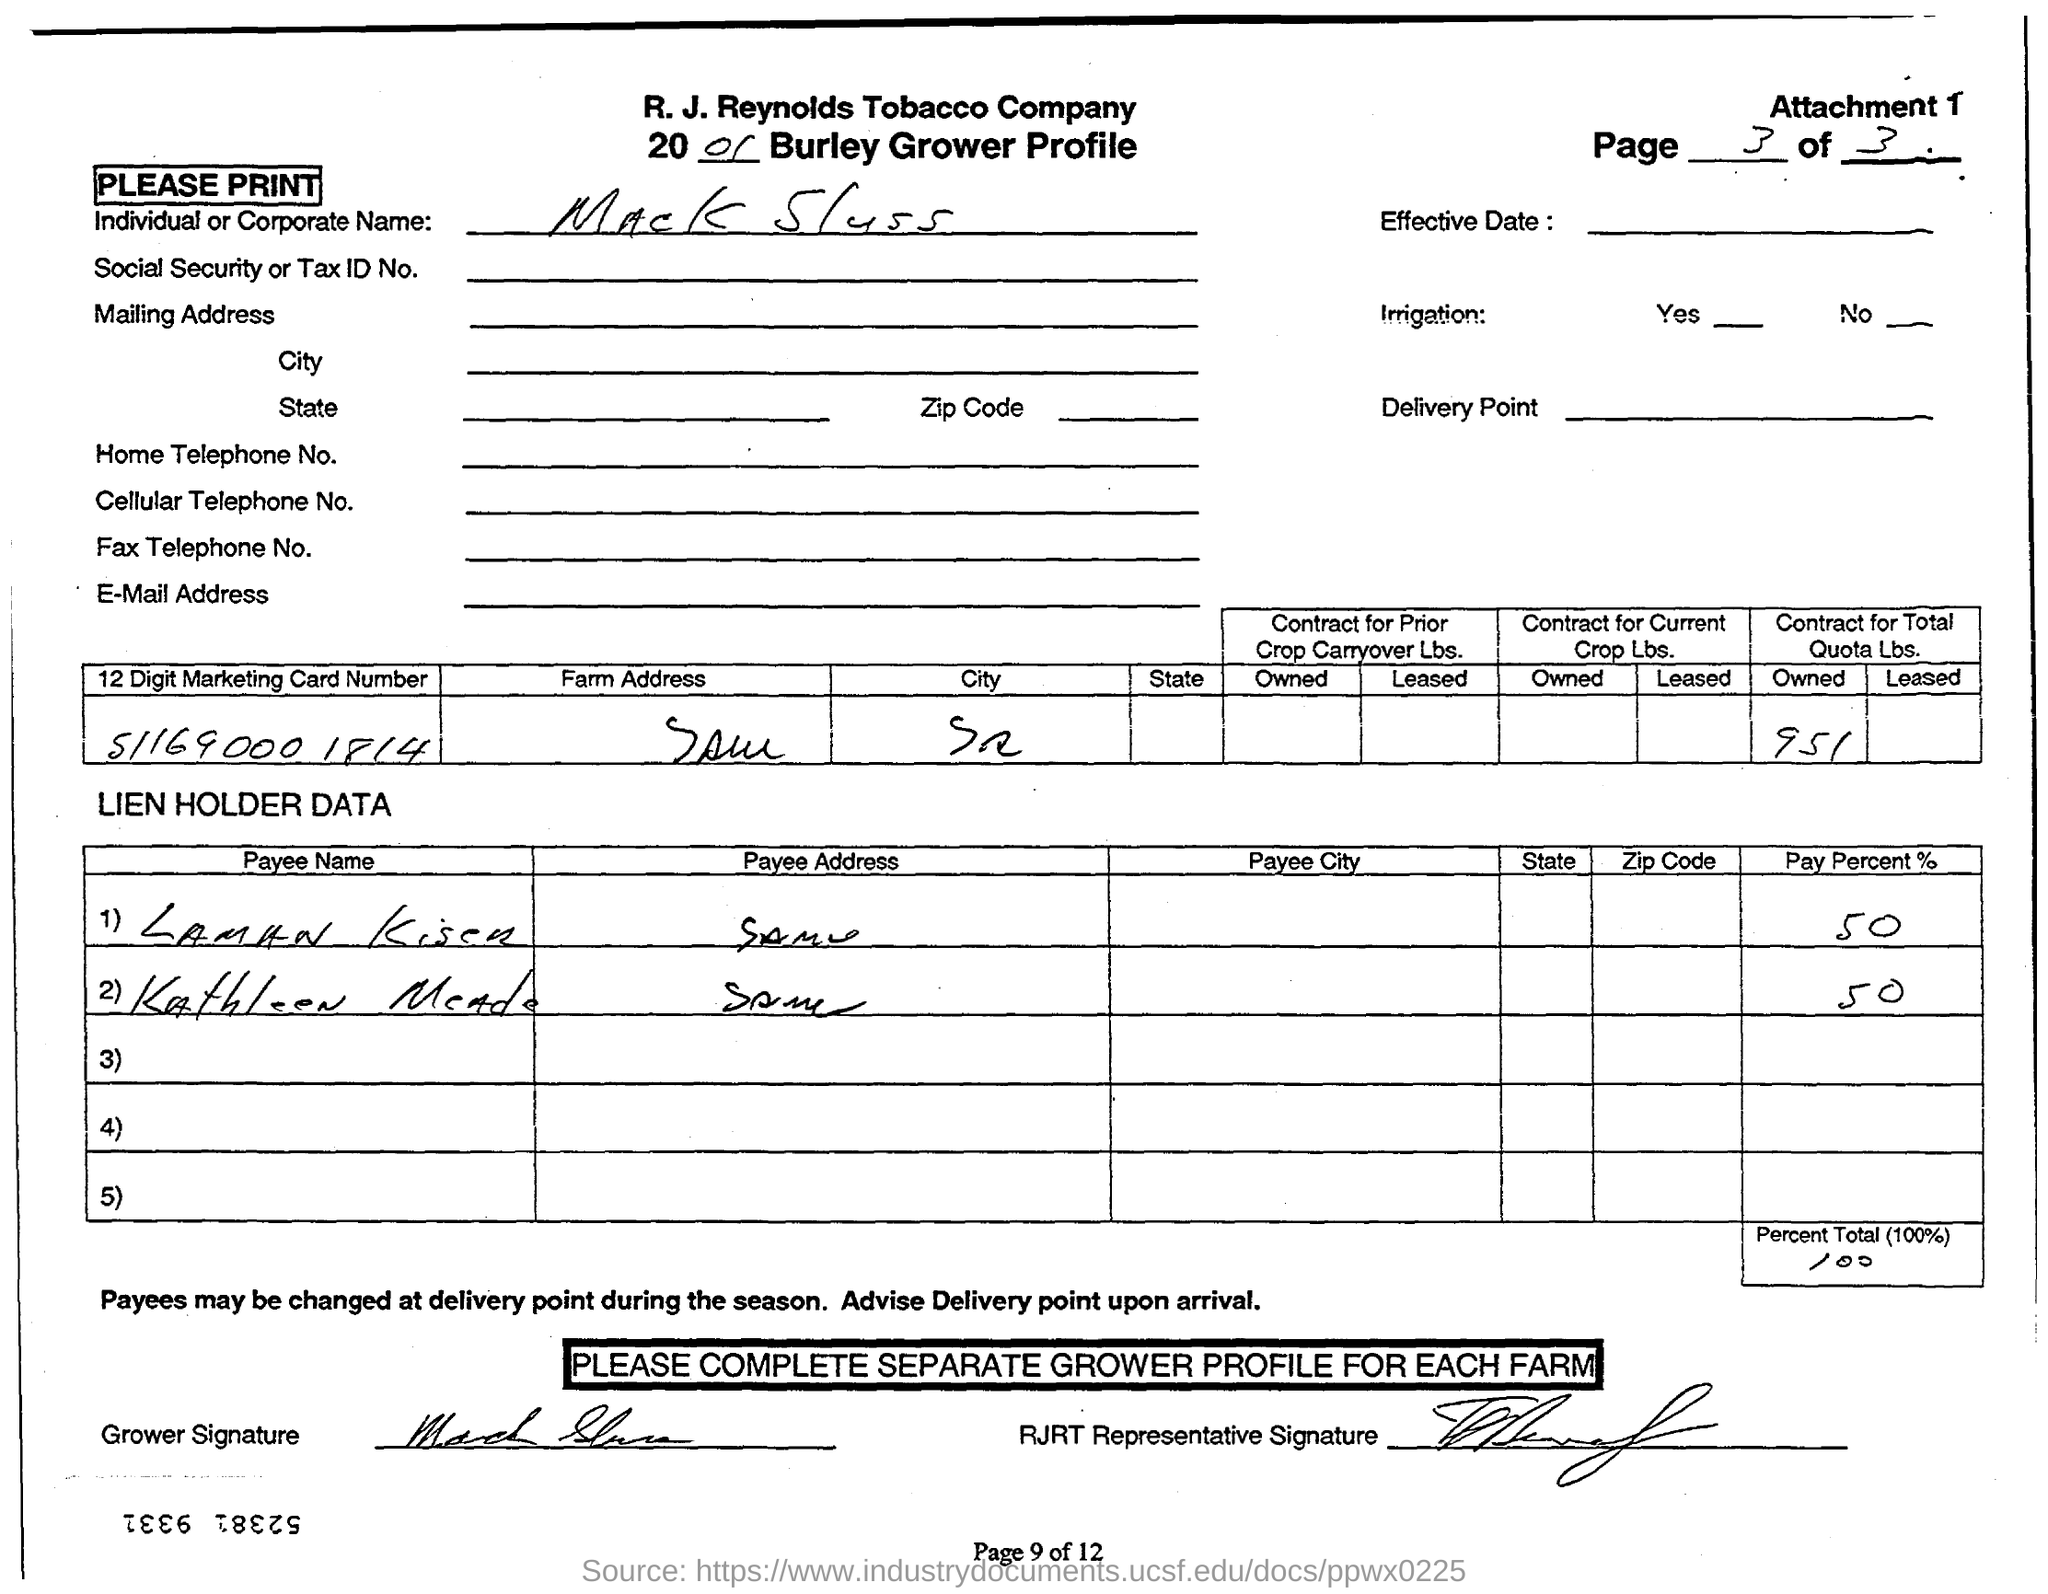List a handful of essential elements in this visual. The 12-digit marketing card number is 51169000 1814. Mack Sluss is the individual or corporate name. 